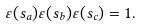Convert formula to latex. <formula><loc_0><loc_0><loc_500><loc_500>\varepsilon ( s _ { a } ) \varepsilon ( s _ { b } ) \varepsilon ( s _ { c } ) = 1 .</formula> 